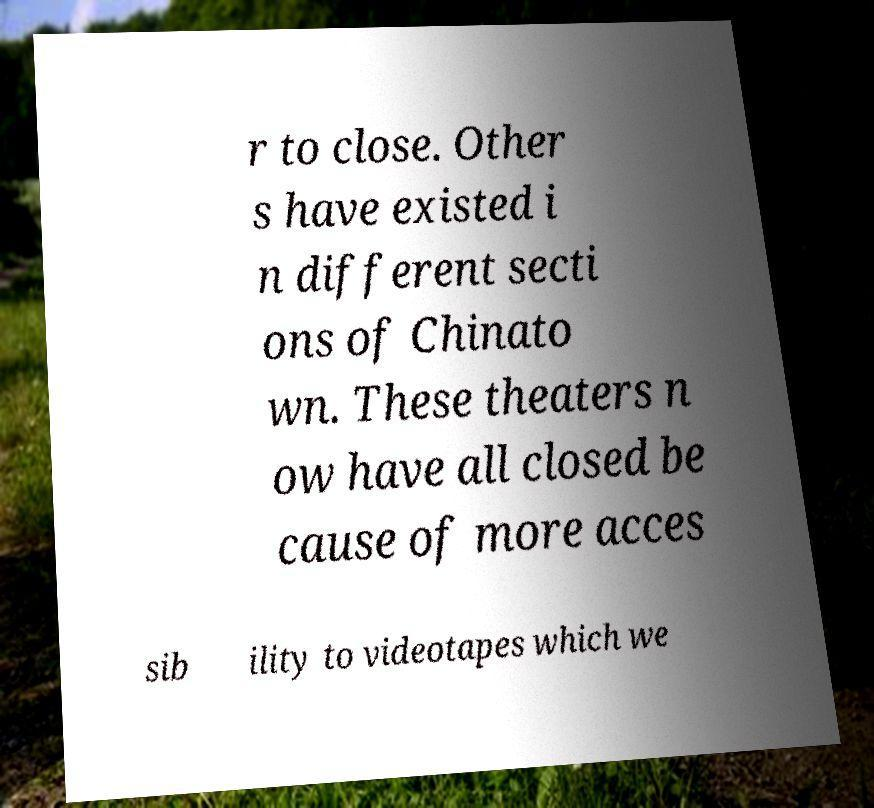Could you extract and type out the text from this image? r to close. Other s have existed i n different secti ons of Chinato wn. These theaters n ow have all closed be cause of more acces sib ility to videotapes which we 